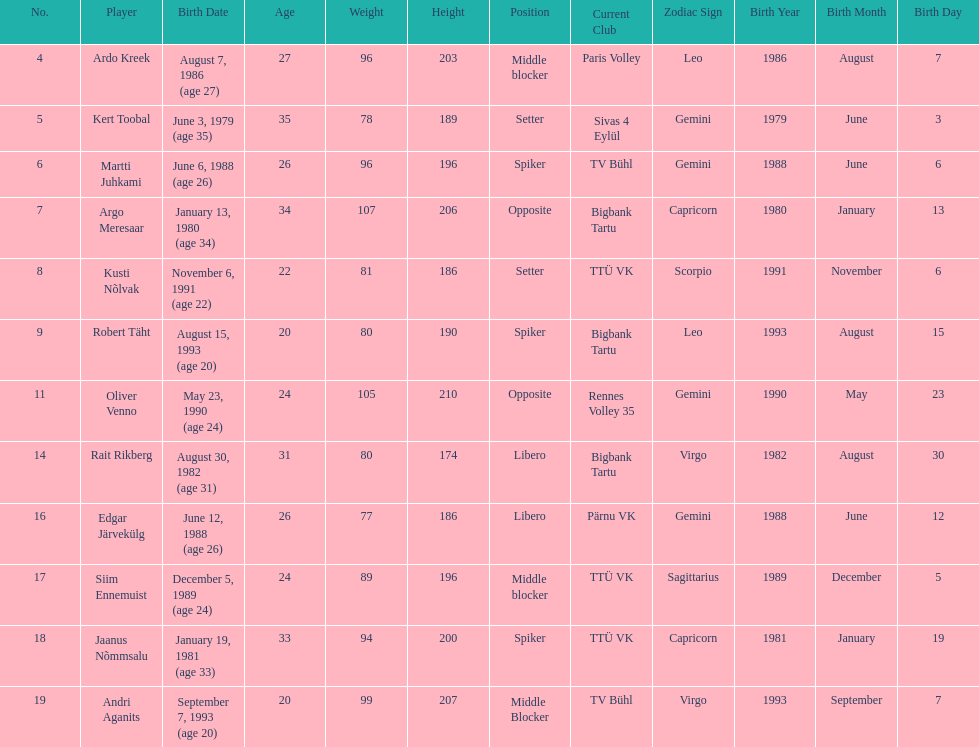How many members of estonia's men's national volleyball team were born in 1988? 2. 